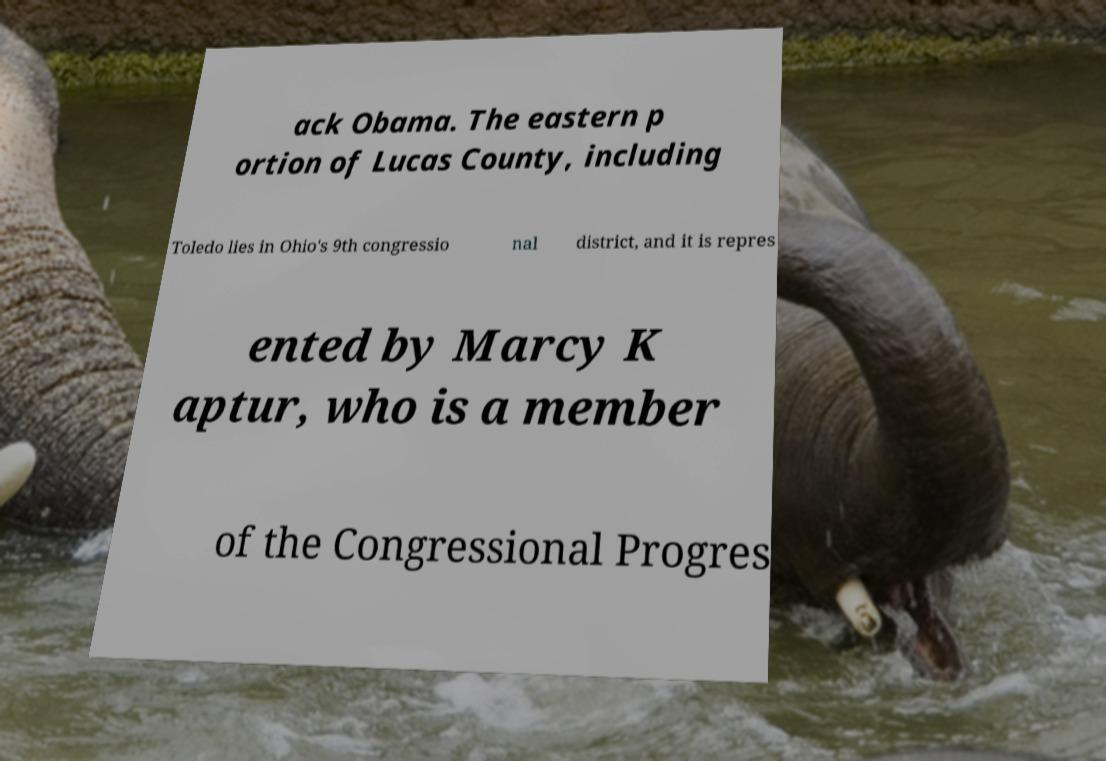Could you assist in decoding the text presented in this image and type it out clearly? ack Obama. The eastern p ortion of Lucas County, including Toledo lies in Ohio's 9th congressio nal district, and it is repres ented by Marcy K aptur, who is a member of the Congressional Progres 